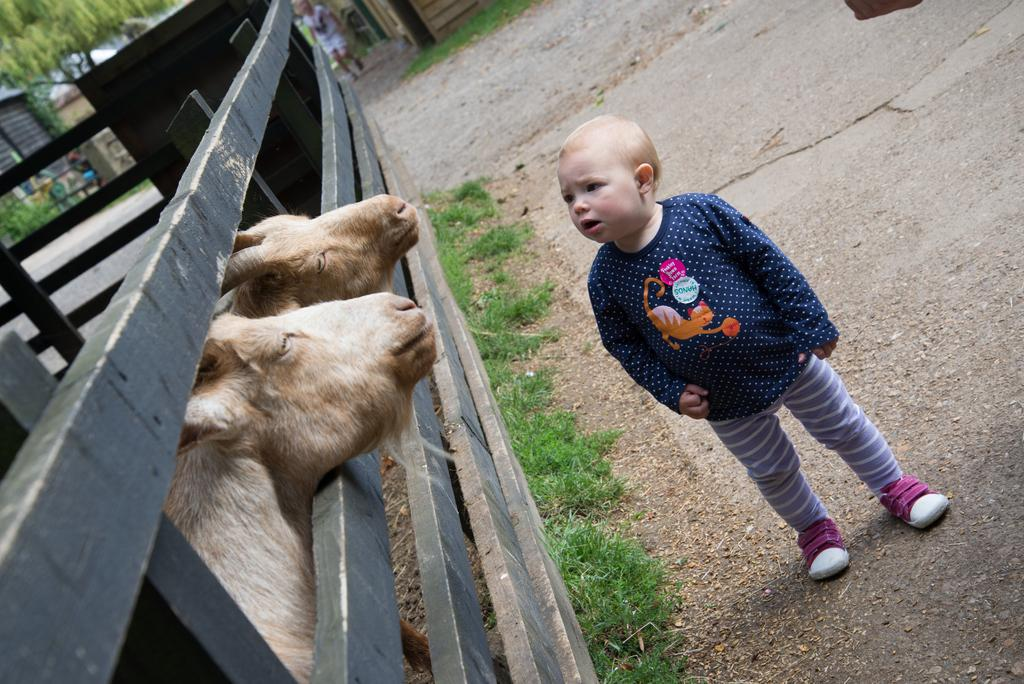What is the main subject of the image? There is a kid standing in the image. What else can be seen in the image besides the kid? There are animals, grass, a fence, and a person in the background of the image. What is visible in the background of the image? There is a wall and a tree in the background of the image. What is the title of the book the kid is reading in the image? There is no book visible in the image, so it is not possible to determine the title. 